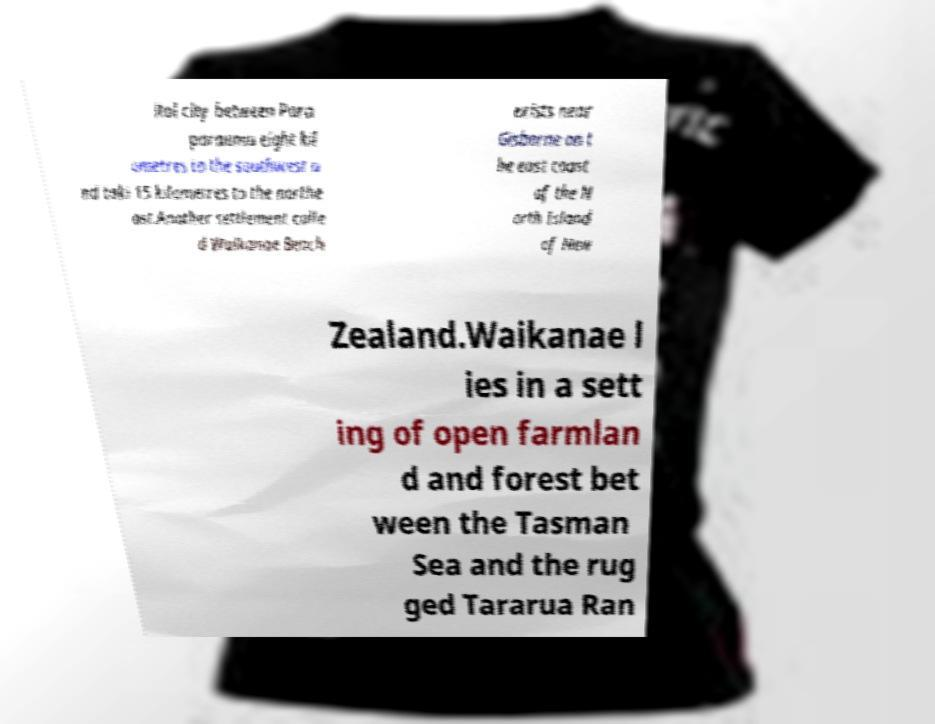I need the written content from this picture converted into text. Can you do that? ital city between Para paraumu eight kil ometres to the southwest a nd taki 15 kilometres to the northe ast.Another settlement calle d Waikanae Beach exists near Gisborne on t he east coast of the N orth Island of New Zealand.Waikanae l ies in a sett ing of open farmlan d and forest bet ween the Tasman Sea and the rug ged Tararua Ran 